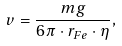<formula> <loc_0><loc_0><loc_500><loc_500>v = \frac { m g } { 6 \pi \cdot r _ { F e } \cdot \eta } ,</formula> 